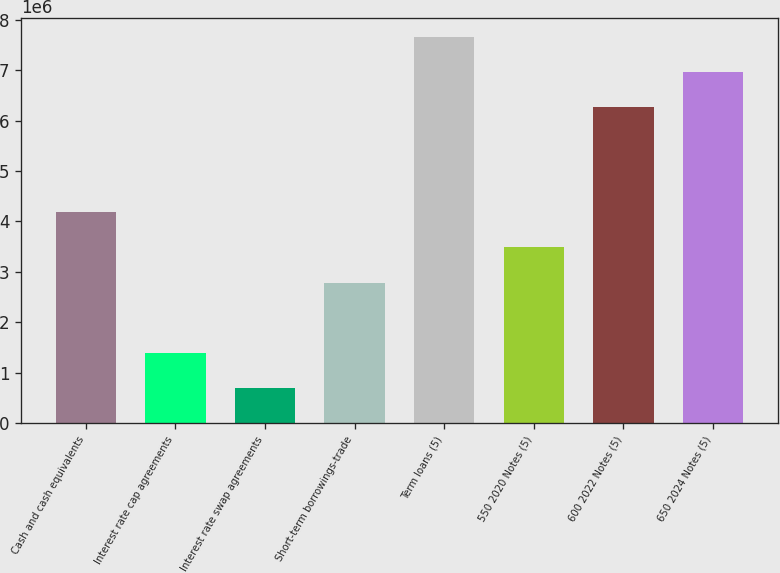<chart> <loc_0><loc_0><loc_500><loc_500><bar_chart><fcel>Cash and cash equivalents<fcel>Interest rate cap agreements<fcel>Interest rate swap agreements<fcel>Short-term borrowings-trade<fcel>Term loans (5)<fcel>550 2020 Notes (5)<fcel>600 2022 Notes (5)<fcel>650 2024 Notes (5)<nl><fcel>4.18054e+06<fcel>1.39545e+06<fcel>699177<fcel>2.78799e+06<fcel>7.6619e+06<fcel>3.48427e+06<fcel>6.26936e+06<fcel>6.96563e+06<nl></chart> 